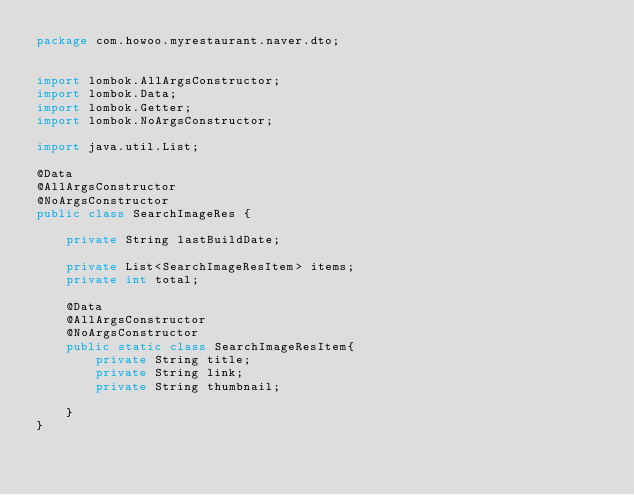<code> <loc_0><loc_0><loc_500><loc_500><_Java_>package com.howoo.myrestaurant.naver.dto;


import lombok.AllArgsConstructor;
import lombok.Data;
import lombok.Getter;
import lombok.NoArgsConstructor;

import java.util.List;

@Data
@AllArgsConstructor
@NoArgsConstructor
public class SearchImageRes {

    private String lastBuildDate;

    private List<SearchImageResItem> items;
    private int total;

    @Data
    @AllArgsConstructor
    @NoArgsConstructor
    public static class SearchImageResItem{
        private String title;
        private String link;
        private String thumbnail;

    }
}
</code> 